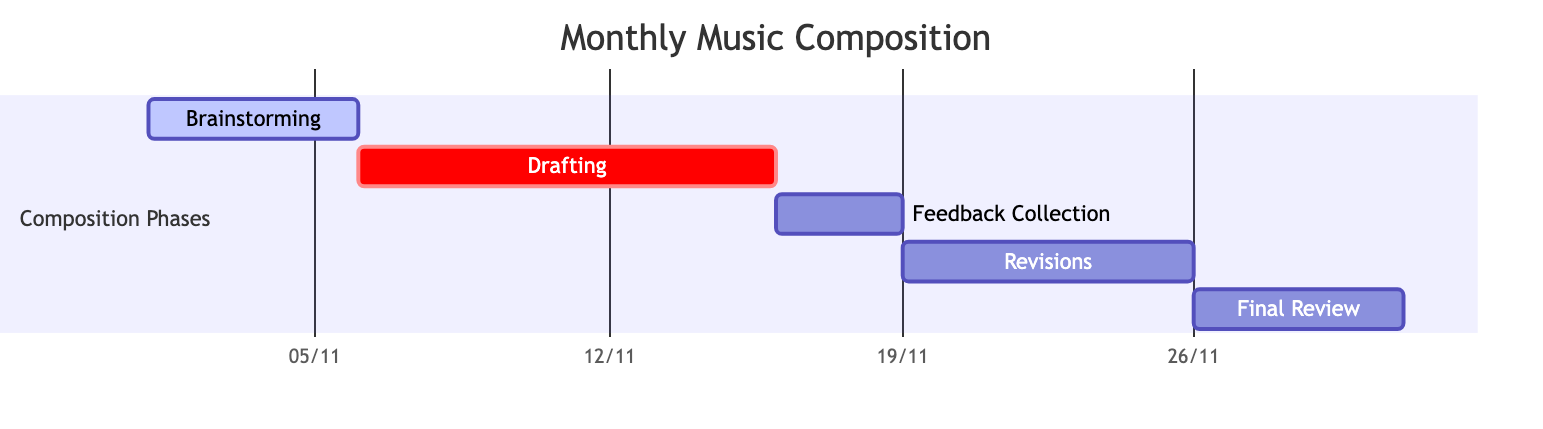What is the duration of the Drafting phase? The Drafting phase is listed with a duration attribute of 10 days.
Answer: 10 days When does the Feedback Collection phase start? The start date for the Feedback Collection phase is provided as November 16, 2023.
Answer: November 16, 2023 Which phase comes directly after Revisions? After the Revisions phase, as per the timeline, the Final Review phase follows.
Answer: Final Review How many phases are there in total? By counting each section labeled in the diagram, there are five phases displayed.
Answer: 5 What is the end date of the Brainstorming phase? The end date for Brainstorming is given as November 5, 2023, when considering the start date and duration.
Answer: November 5, 2023 Which phase has the longest duration? Among all phases, the Drafting phase has the longest duration of 10 days.
Answer: Drafting What is the total duration of all the phases combined? Summing the durations of each phase (5+10+3+7+5) equals 30 days total for the entire project.
Answer: 30 days Which phase is set as active? The diagram indicates that the Brainstorming phase is marked as active.
Answer: Brainstorming What is the relationship between the Feedback Collection and Revisions phases? The Feedback Collection phase directly precedes the Revisions phase, creating a sequential relationship.
Answer: Sequential relationship 